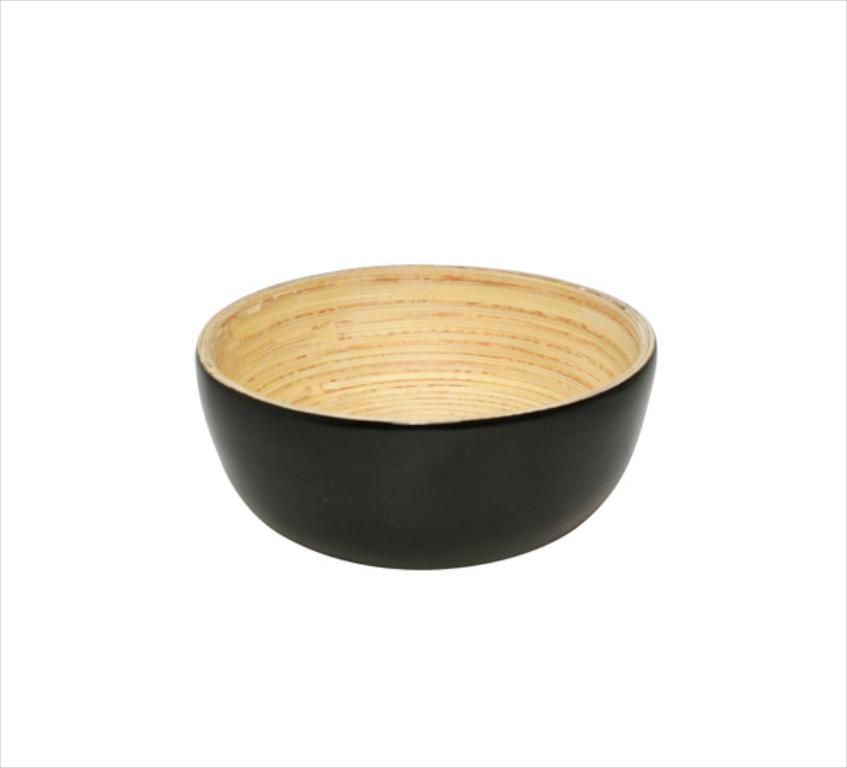What type of material is the bowl made of in the image? The bowl in the image is made of wood. How many clams are present in the wooden bowl in the image? There is no mention of clams in the image, as it only features a wooden bowl. 